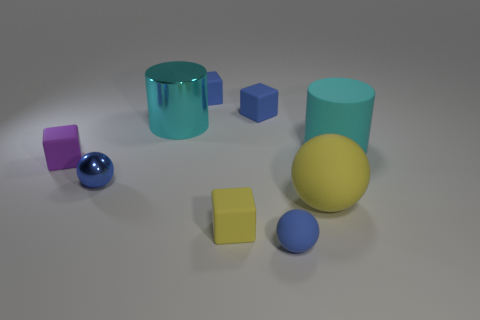What number of other objects are there of the same color as the small metallic ball?
Ensure brevity in your answer.  3. The cyan thing to the left of the large ball has what shape?
Keep it short and to the point. Cylinder. Do the yellow sphere and the small purple cube have the same material?
Your answer should be very brief. Yes. Is there anything else that has the same size as the yellow cube?
Provide a short and direct response. Yes. There is a purple rubber cube; what number of blue matte objects are behind it?
Provide a short and direct response. 2. The large cyan object that is left of the tiny blue rubber thing in front of the matte cylinder is what shape?
Your answer should be compact. Cylinder. Is there anything else that has the same shape as the large yellow thing?
Give a very brief answer. Yes. Is the number of large yellow rubber objects left of the big metallic thing greater than the number of metal objects?
Offer a very short reply. No. What number of big cyan cylinders are in front of the large cyan cylinder that is to the left of the large cyan rubber cylinder?
Offer a very short reply. 1. There is a yellow object that is on the left side of the blue rubber thing that is in front of the block on the left side of the small shiny thing; what shape is it?
Offer a terse response. Cube. 